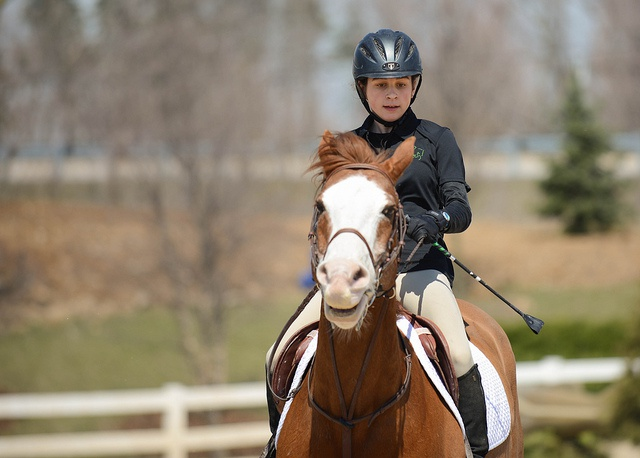Describe the objects in this image and their specific colors. I can see horse in olive, maroon, white, black, and gray tones and people in olive, black, gray, and beige tones in this image. 